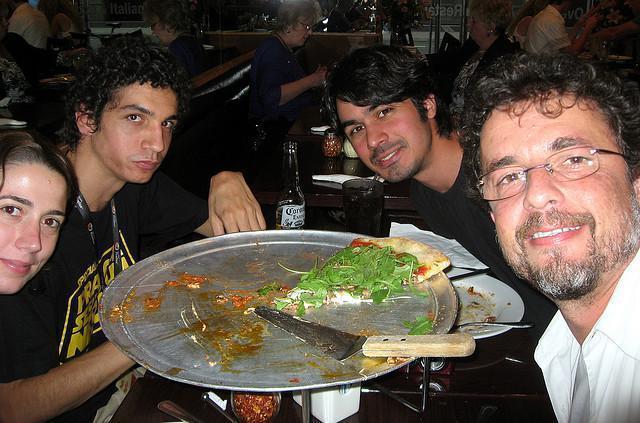What is covering the last slice of pizza available on the tray?
Pick the correct solution from the four options below to address the question.
Options: Pepperoni, mushrooms, spinach, cheese. Spinach. 